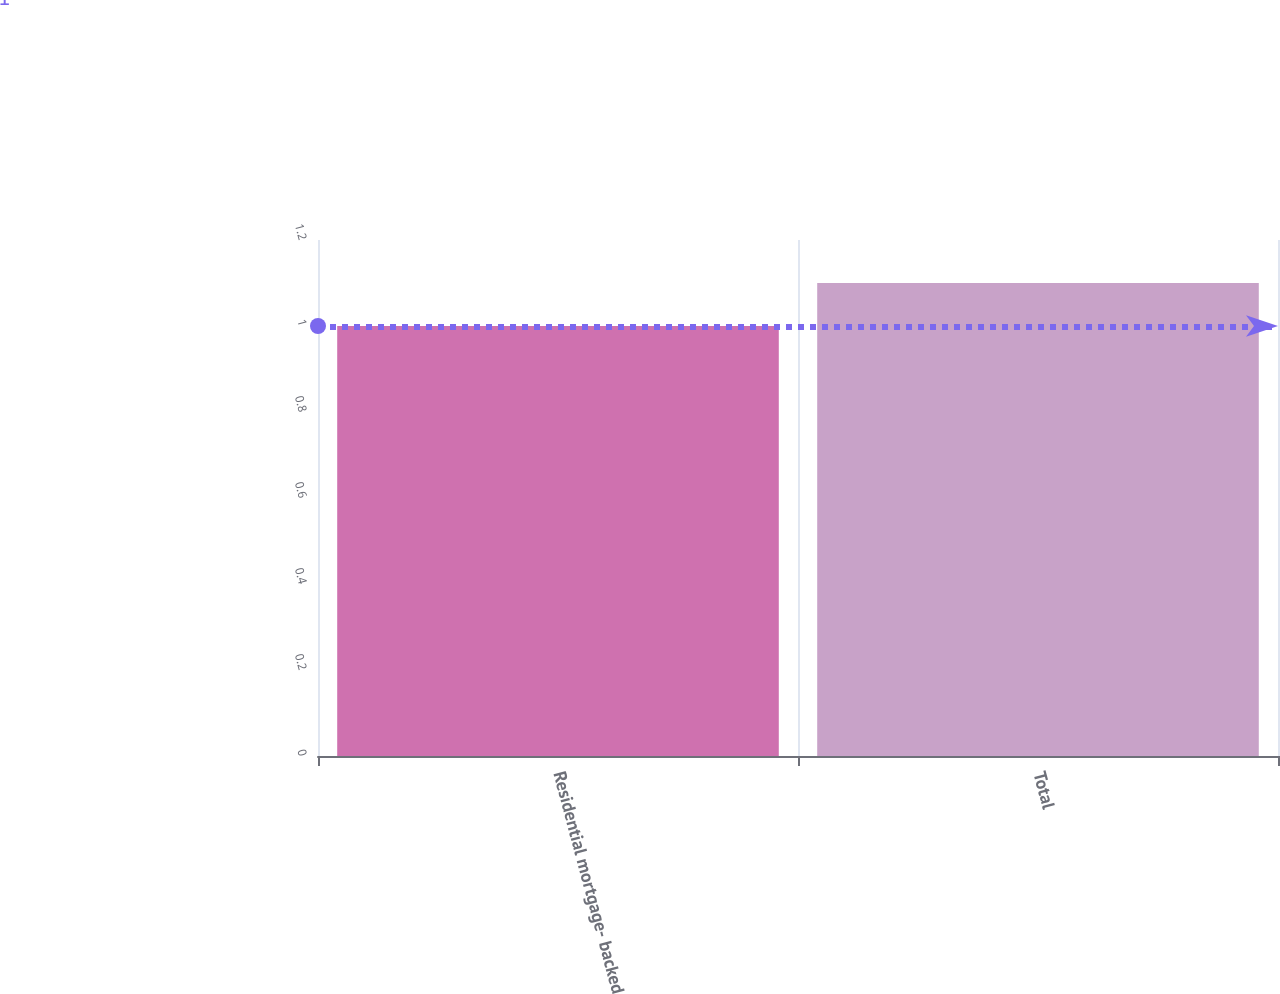Convert chart. <chart><loc_0><loc_0><loc_500><loc_500><bar_chart><fcel>Residential mortgage- backed<fcel>Total<nl><fcel>1<fcel>1.1<nl></chart> 